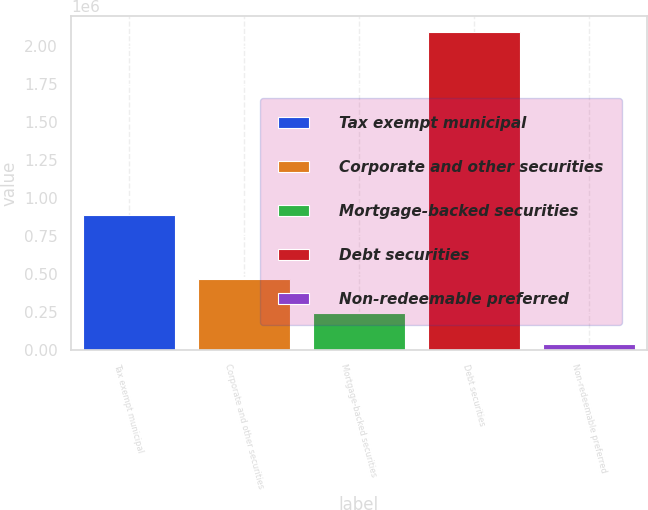Convert chart. <chart><loc_0><loc_0><loc_500><loc_500><bar_chart><fcel>Tax exempt municipal<fcel>Corporate and other securities<fcel>Mortgage-backed securities<fcel>Debt securities<fcel>Non-redeemable preferred<nl><fcel>888592<fcel>469375<fcel>243819<fcel>2.0942e+06<fcel>38221<nl></chart> 